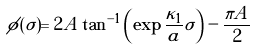<formula> <loc_0><loc_0><loc_500><loc_500>\phi ( \sigma ) = 2 A \tan ^ { - 1 } \left ( \exp { \frac { \kappa _ { 1 } } { a } \sigma } \right ) - \frac { \pi A } { 2 }</formula> 